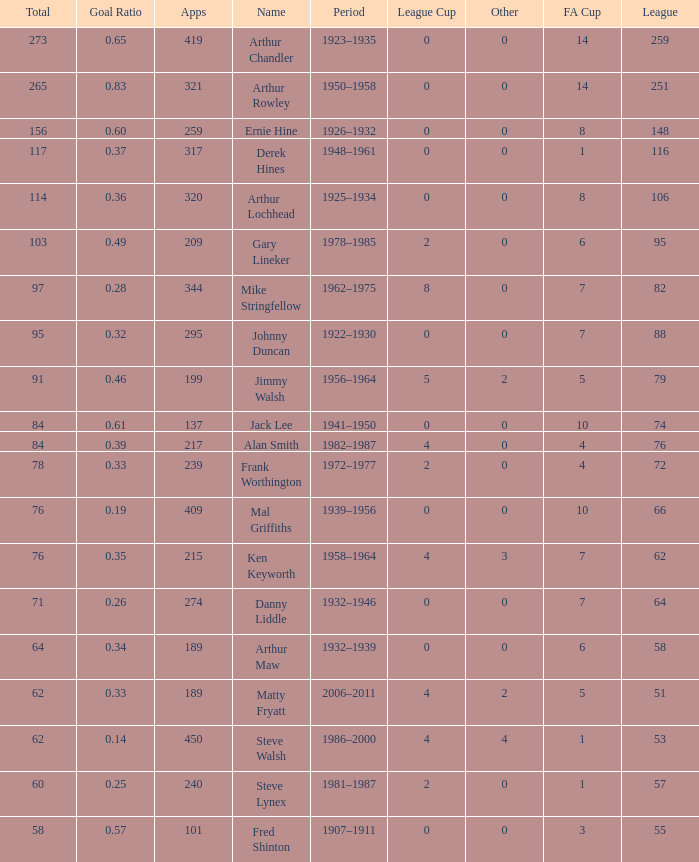What's the highest FA Cup with the Name of Alan Smith, and League Cup smaller than 4? None. 